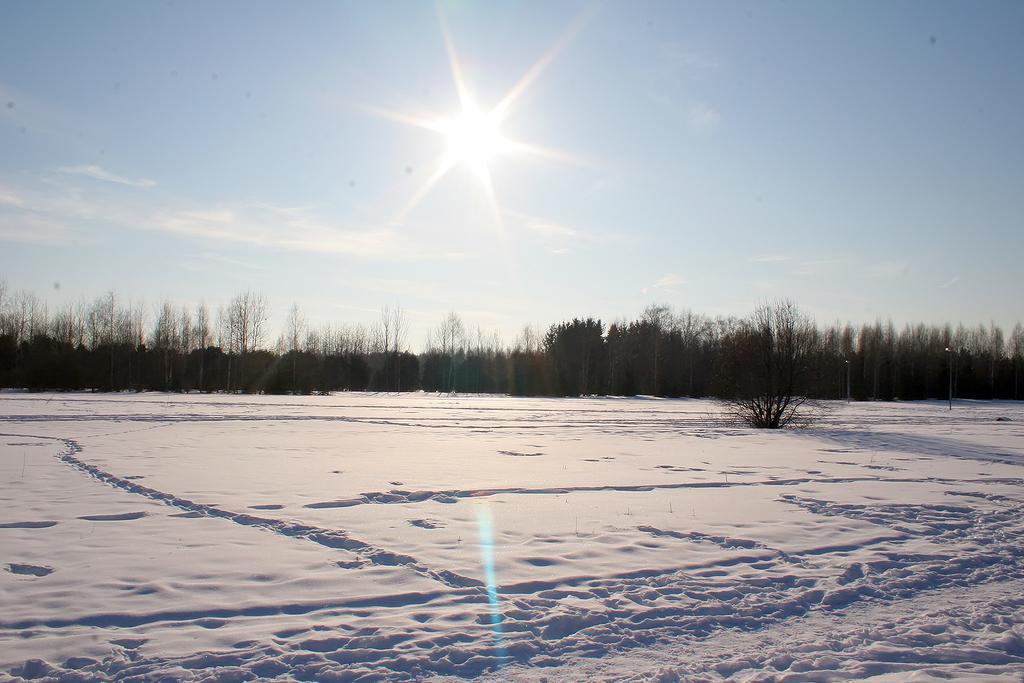How would you summarize this image in a sentence or two? In the image I can see trees and the snow. In the background I can see the sky and the sun. 